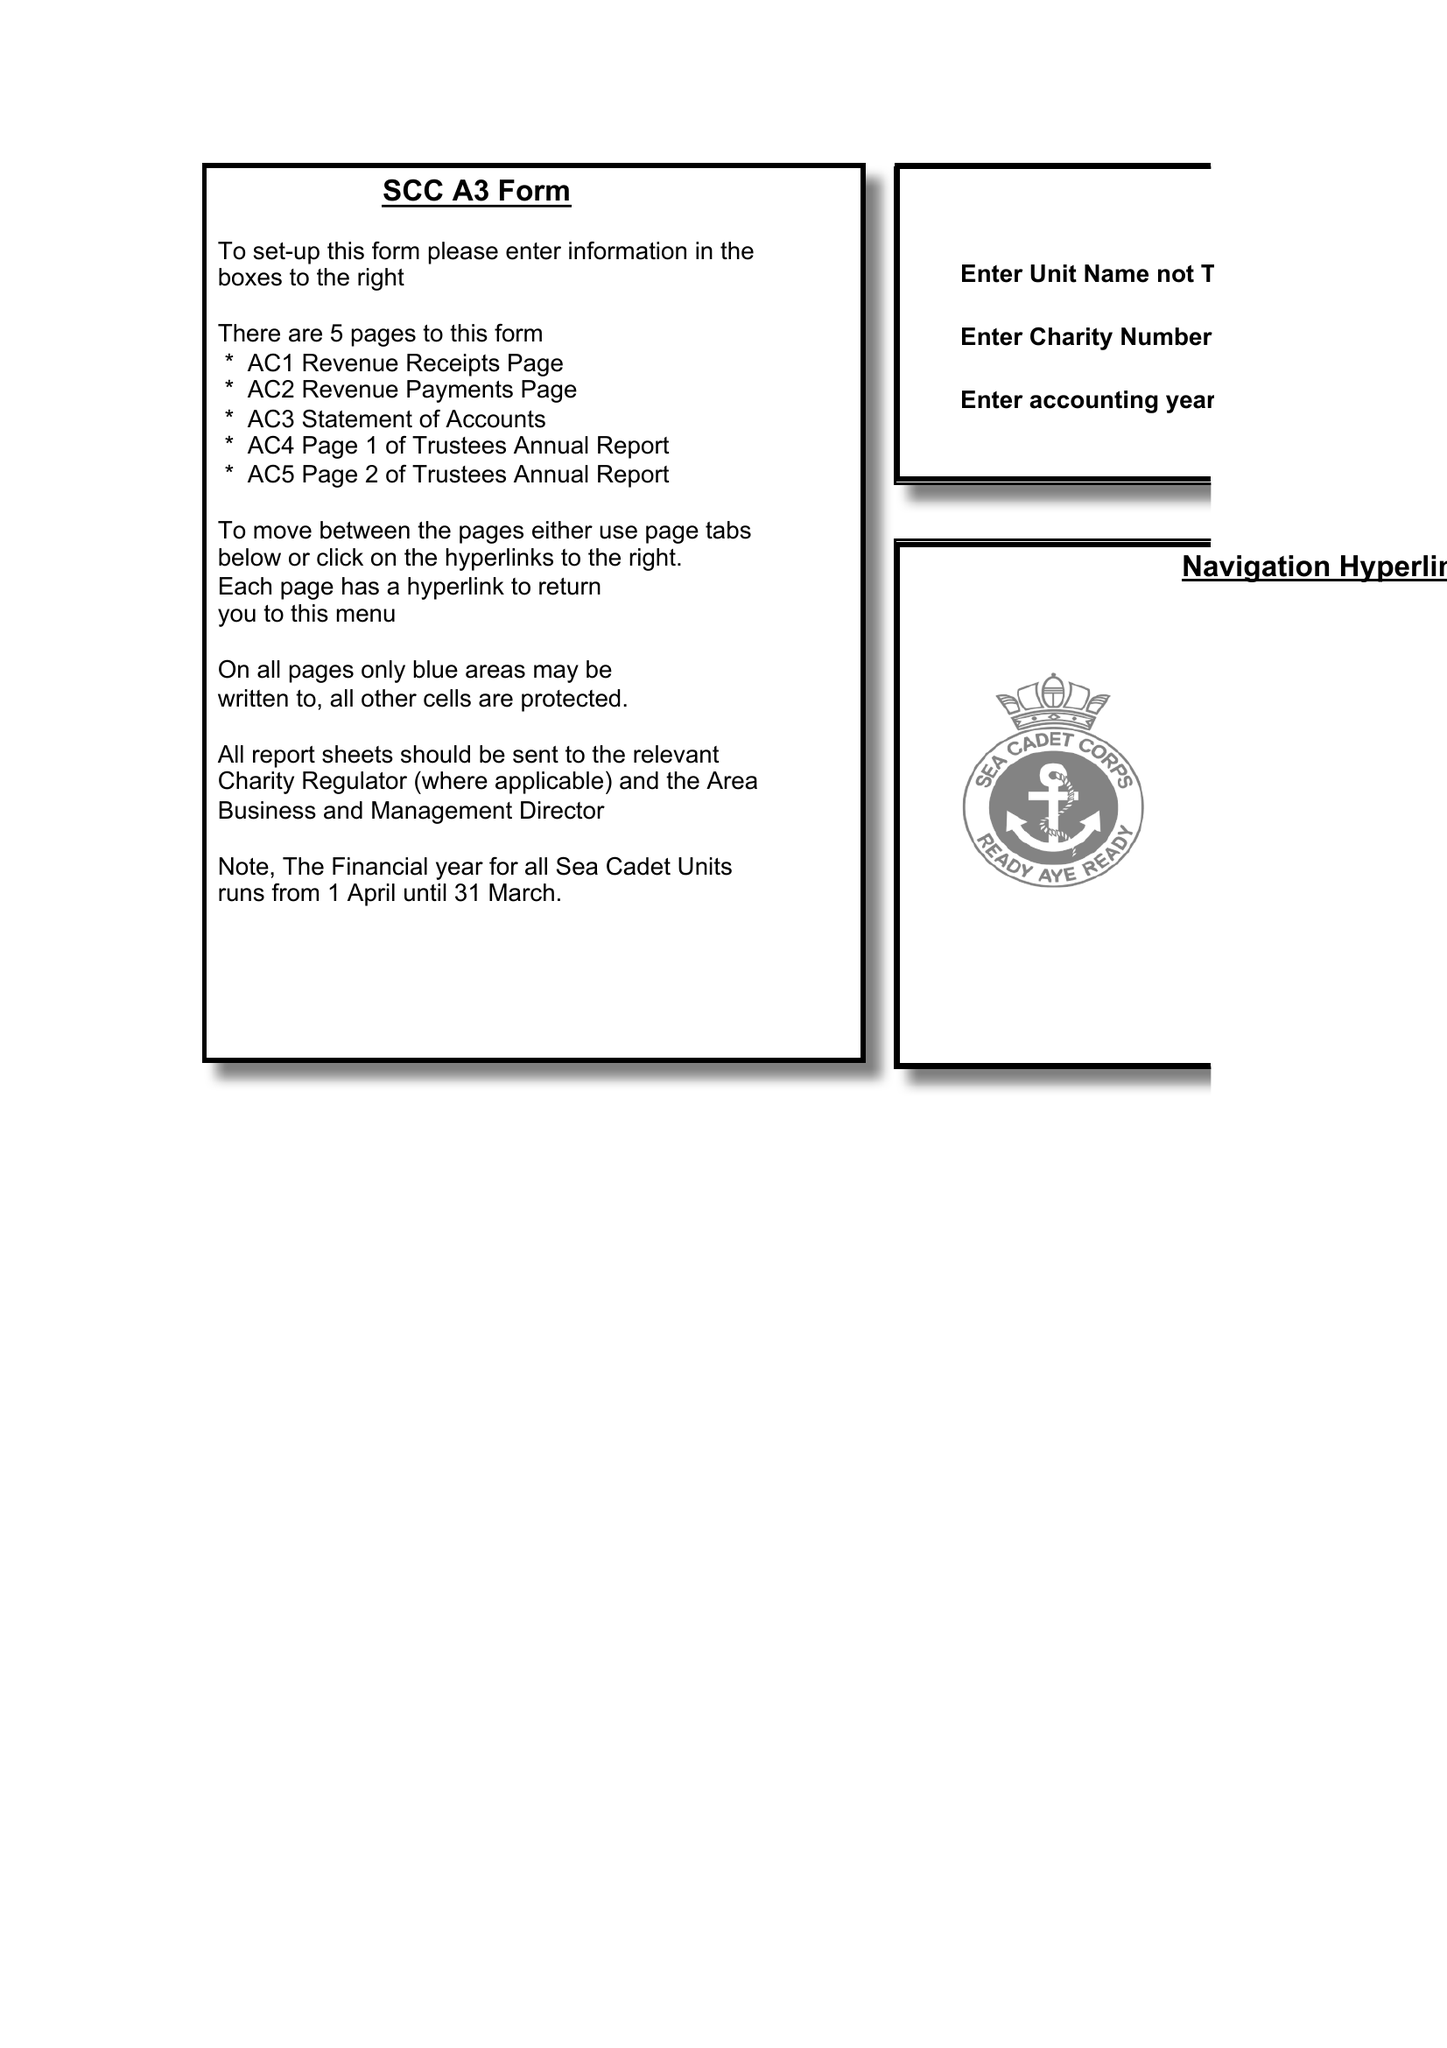What is the value for the spending_annually_in_british_pounds?
Answer the question using a single word or phrase. 48240.75 